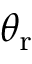Convert formula to latex. <formula><loc_0><loc_0><loc_500><loc_500>\theta _ { r }</formula> 